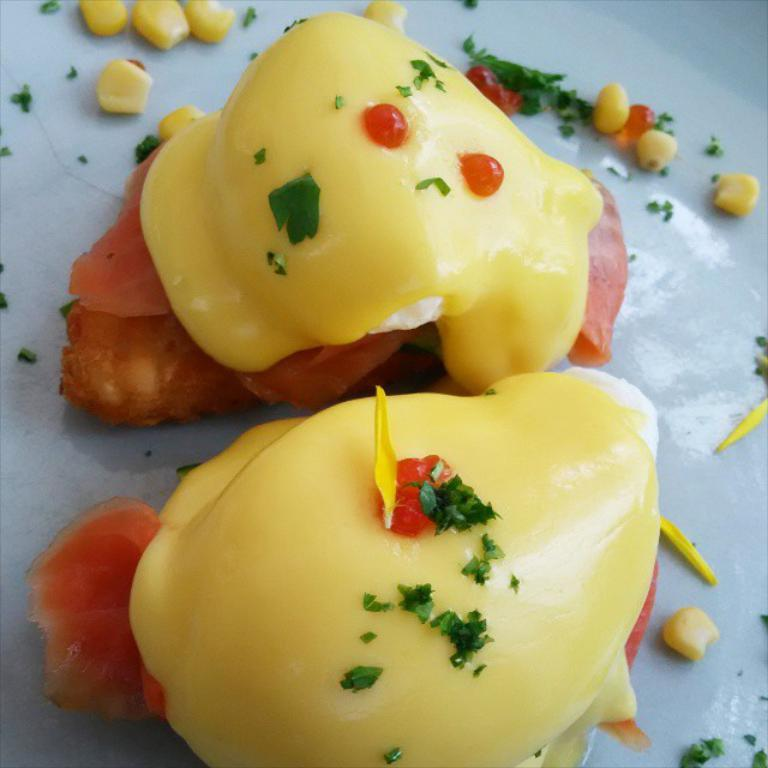What type of food item is in the foreground of the image? There is a dessert item in the foreground of the image. What is the color of the surface on which the dessert item is placed? The dessert item is on a white surface. How many fingers can be seen touching the dessert item in the image? There are no fingers visible touching the dessert item in the image. What time of day is depicted in the image? The time of day is not discernible from the image. What type of fruit is present in the image? There is no fruit, including bananas, present in the image. 